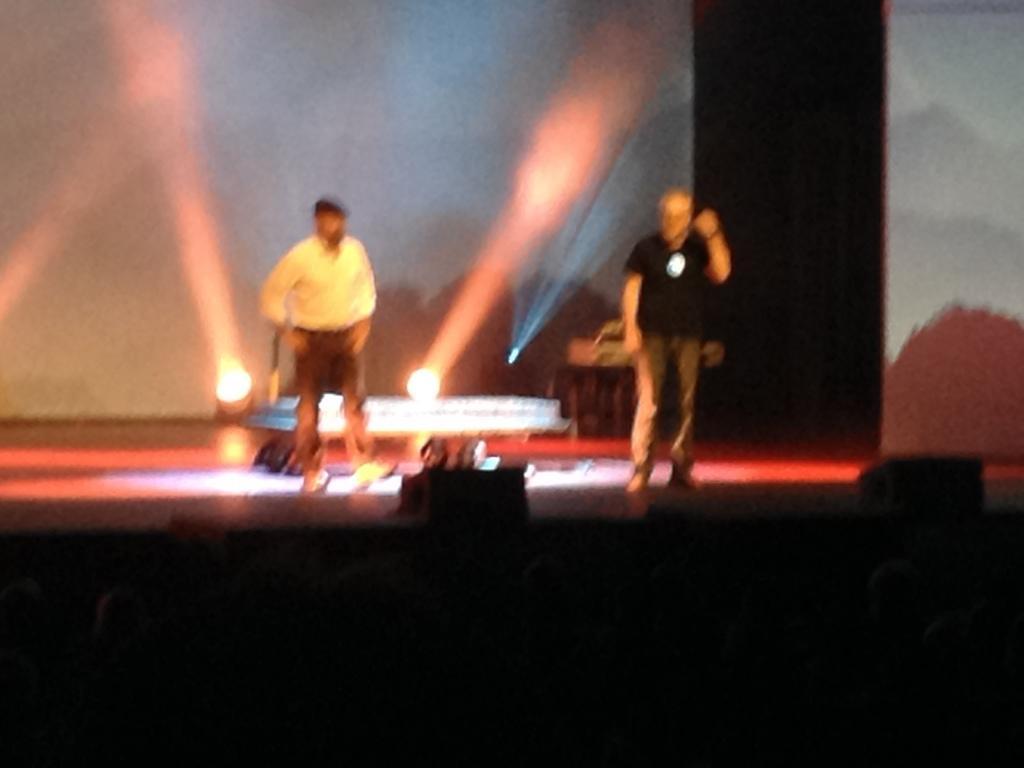Can you describe this image briefly? This image is taken indoors. In the middle of the image there is a dais and there are two lights on the dais. Two men are standing on the dais. In the background there are two lights and there is a screen. 